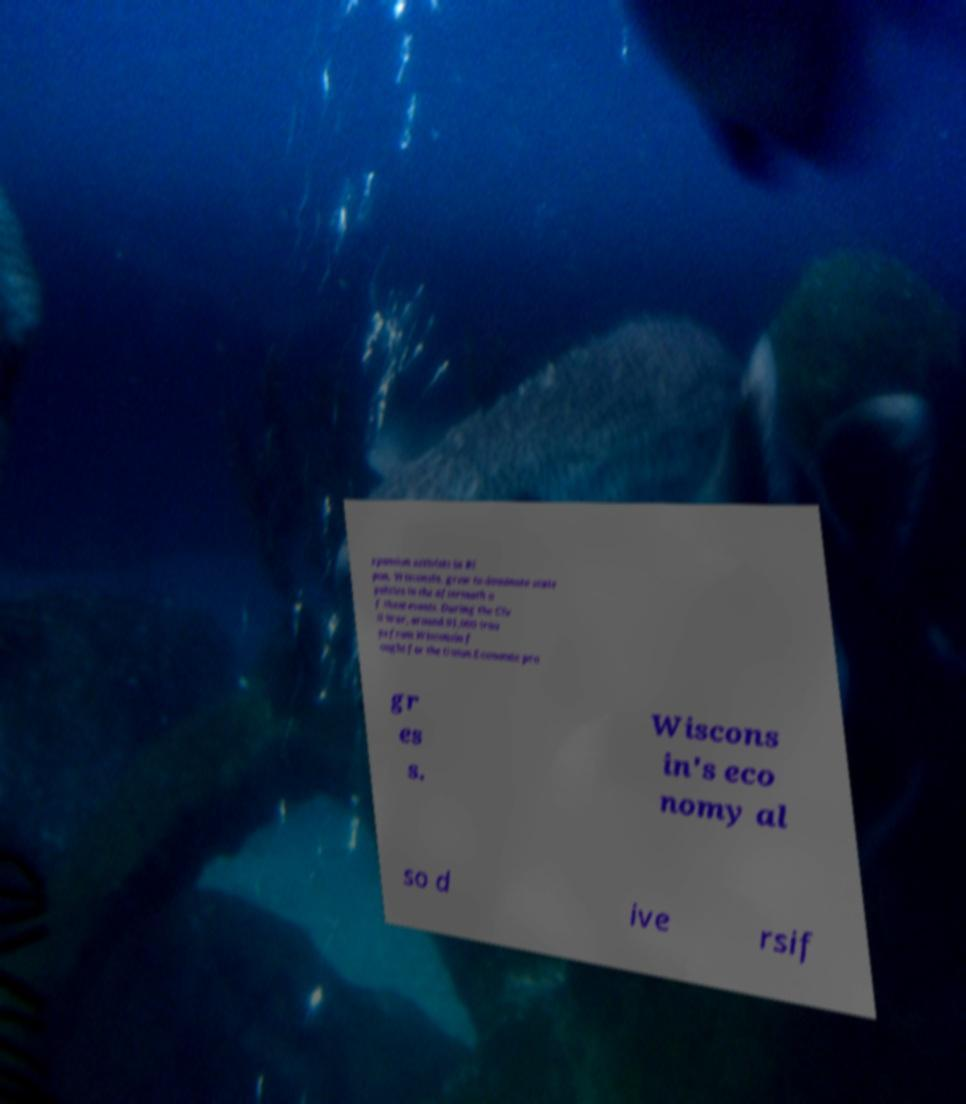For documentation purposes, I need the text within this image transcribed. Could you provide that? xpansion activists in Ri pon, Wisconsin, grew to dominate state politics in the aftermath o f these events. During the Civ il War, around 91,000 troo ps from Wisconsin f ought for the Union.Economic pro gr es s. Wiscons in's eco nomy al so d ive rsif 